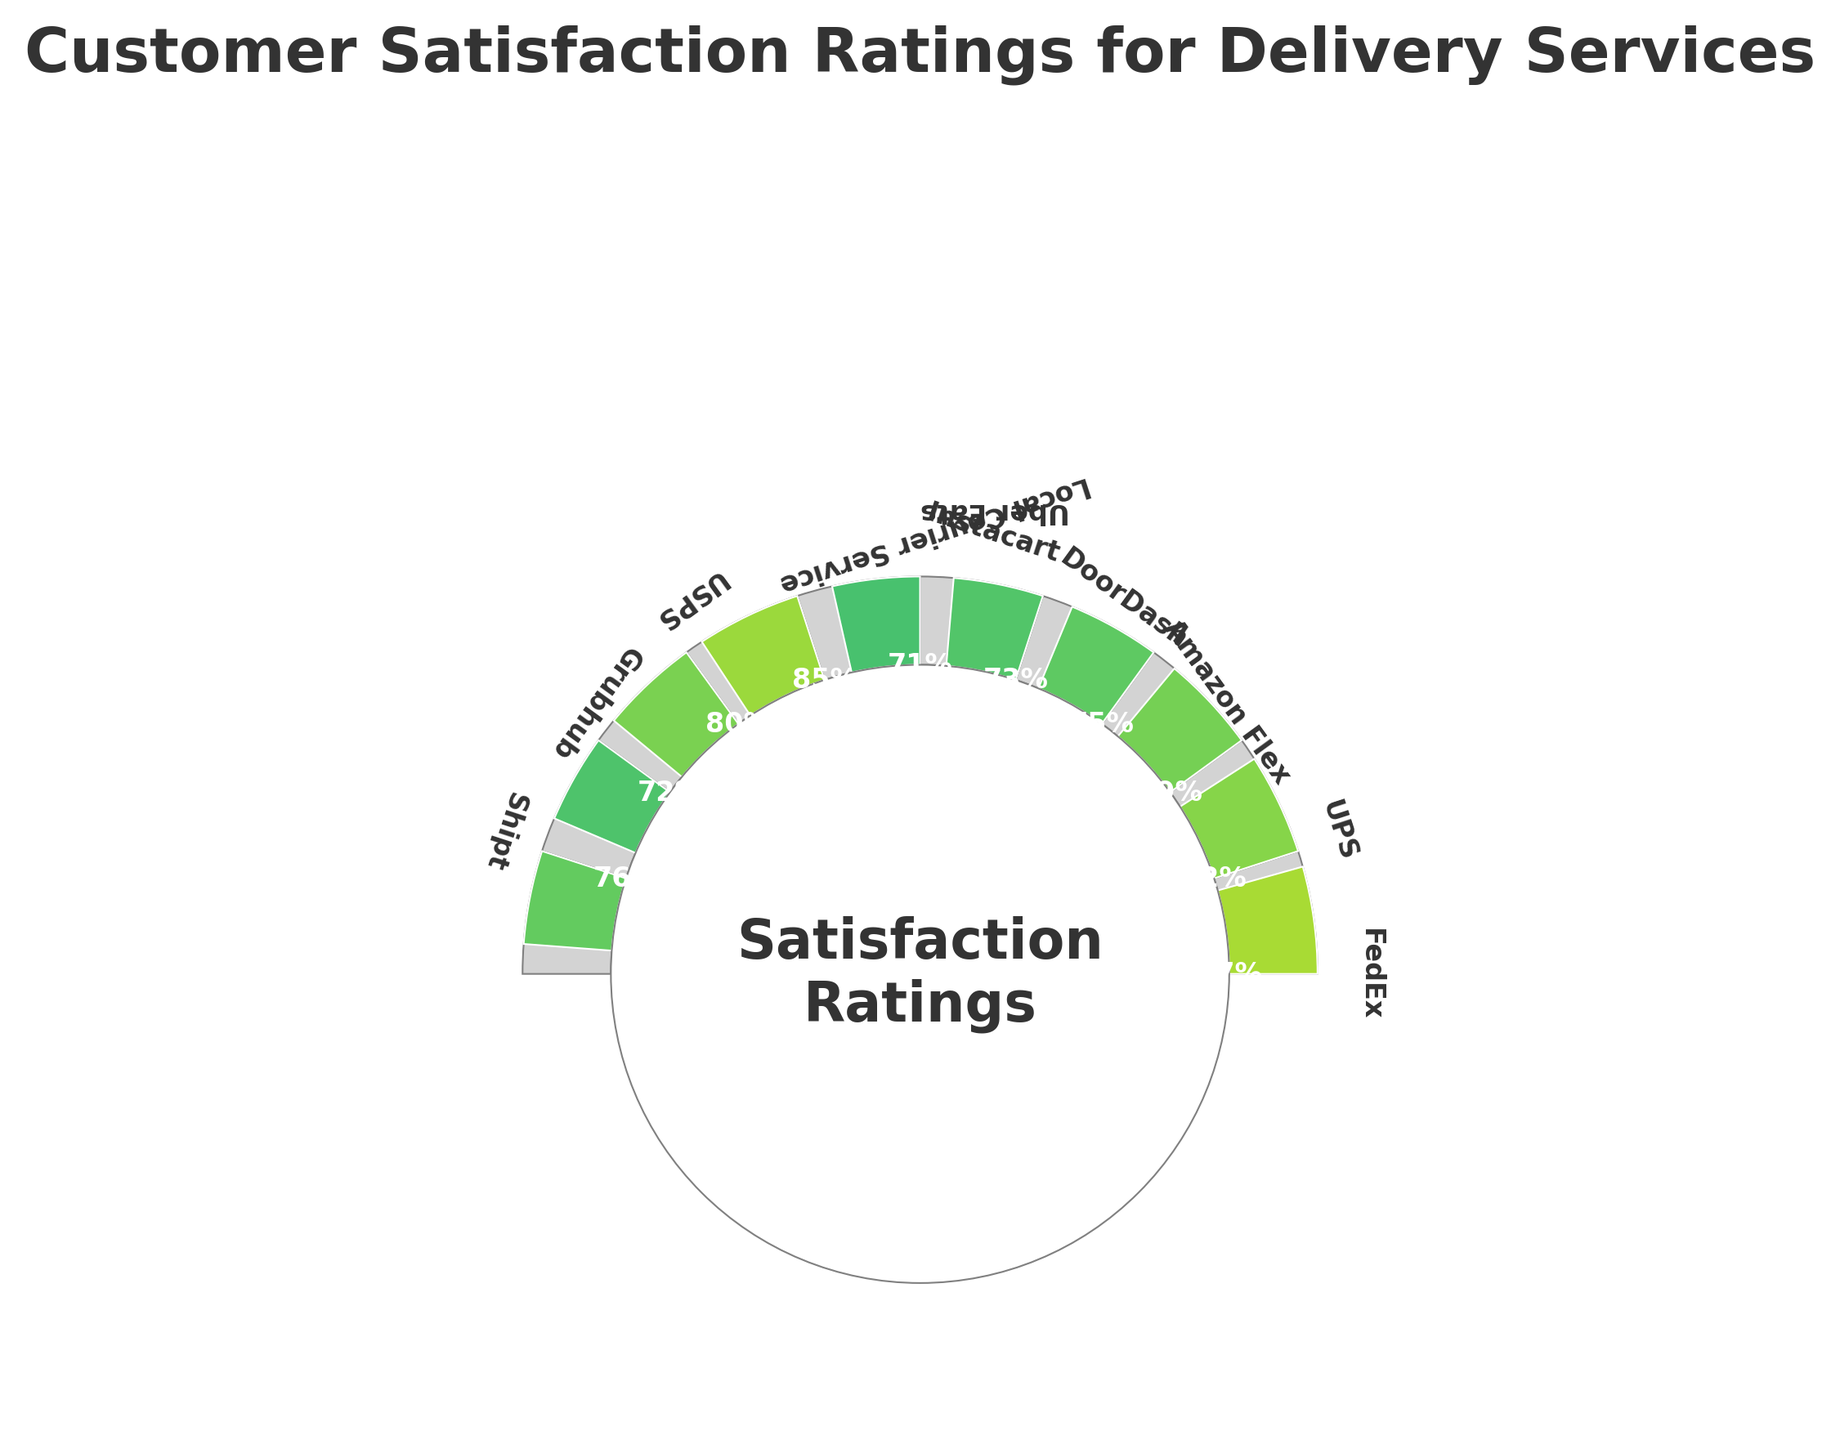What's the title of the figure? The title of the figure is usually at the top and provides an overall description of the chart's contents. In this case, it reads: "Customer Satisfaction Ratings for Delivery Services".
Answer: Customer Satisfaction Ratings for Delivery Services Which service has the highest satisfaction rating? By observing the chart, the service with the most extended wedge segment reaching the farthest represents the highest satisfaction rating. The longest segment corresponds to FedEx with a rating of 87%.
Answer: FedEx Which two services have ratings closest to each other? By comparing the lengths of the wedge segments, we see that DoorDash and Shipt have very close satisfaction ratings. DoorDash is rated 75% and Shipt 76%.
Answer: DoorDash and Shipt What is the total sum of the satisfaction ratings for all services? To find the total, add all the satisfaction ratings: 87 (FedEx) + 82 (UPS) + 79 (Amazon Flex) + 75 (DoorDash) + 73 (Instacart) + 71 (Uber Eats) + 85 (Local Courier Service) + 80 (USPS) + 72 (Grubhub) + 76 (Shipt). The sum is 780.
Answer: 780 How much higher is FedEx's satisfaction rating compared to Grubhub's? FedEx has the highest rating at 87%, while Grubhub's rating is 72%. The difference is 87 - 72 = 15%.
Answer: 15% What is the average satisfaction rating across all delivery services? To calculate the average, divide the total sum of ratings by the number of services: 780 / 10 = 78.
Answer: 78 Which service has the closest satisfaction rating to the average? The average rating is 78. Comparing individual ratings to this value, Amazon Flex's rating is exactly 79, which is closest to 78.
Answer: Amazon Flex How does the Local Courier Service's rating compare to USPS's rating? The Local Courier Service has a satisfaction rating of 85%, while USPS has 80%. The Local Courier Service is 5 percentage points higher.
Answer: 5 percentage points higher Which service has the lowest satisfaction rating? The smallest wedge segment on the chart indicates the lowest satisfaction rating. Uber Eats has the smallest segment with a rating of 71%.
Answer: Uber Eats 